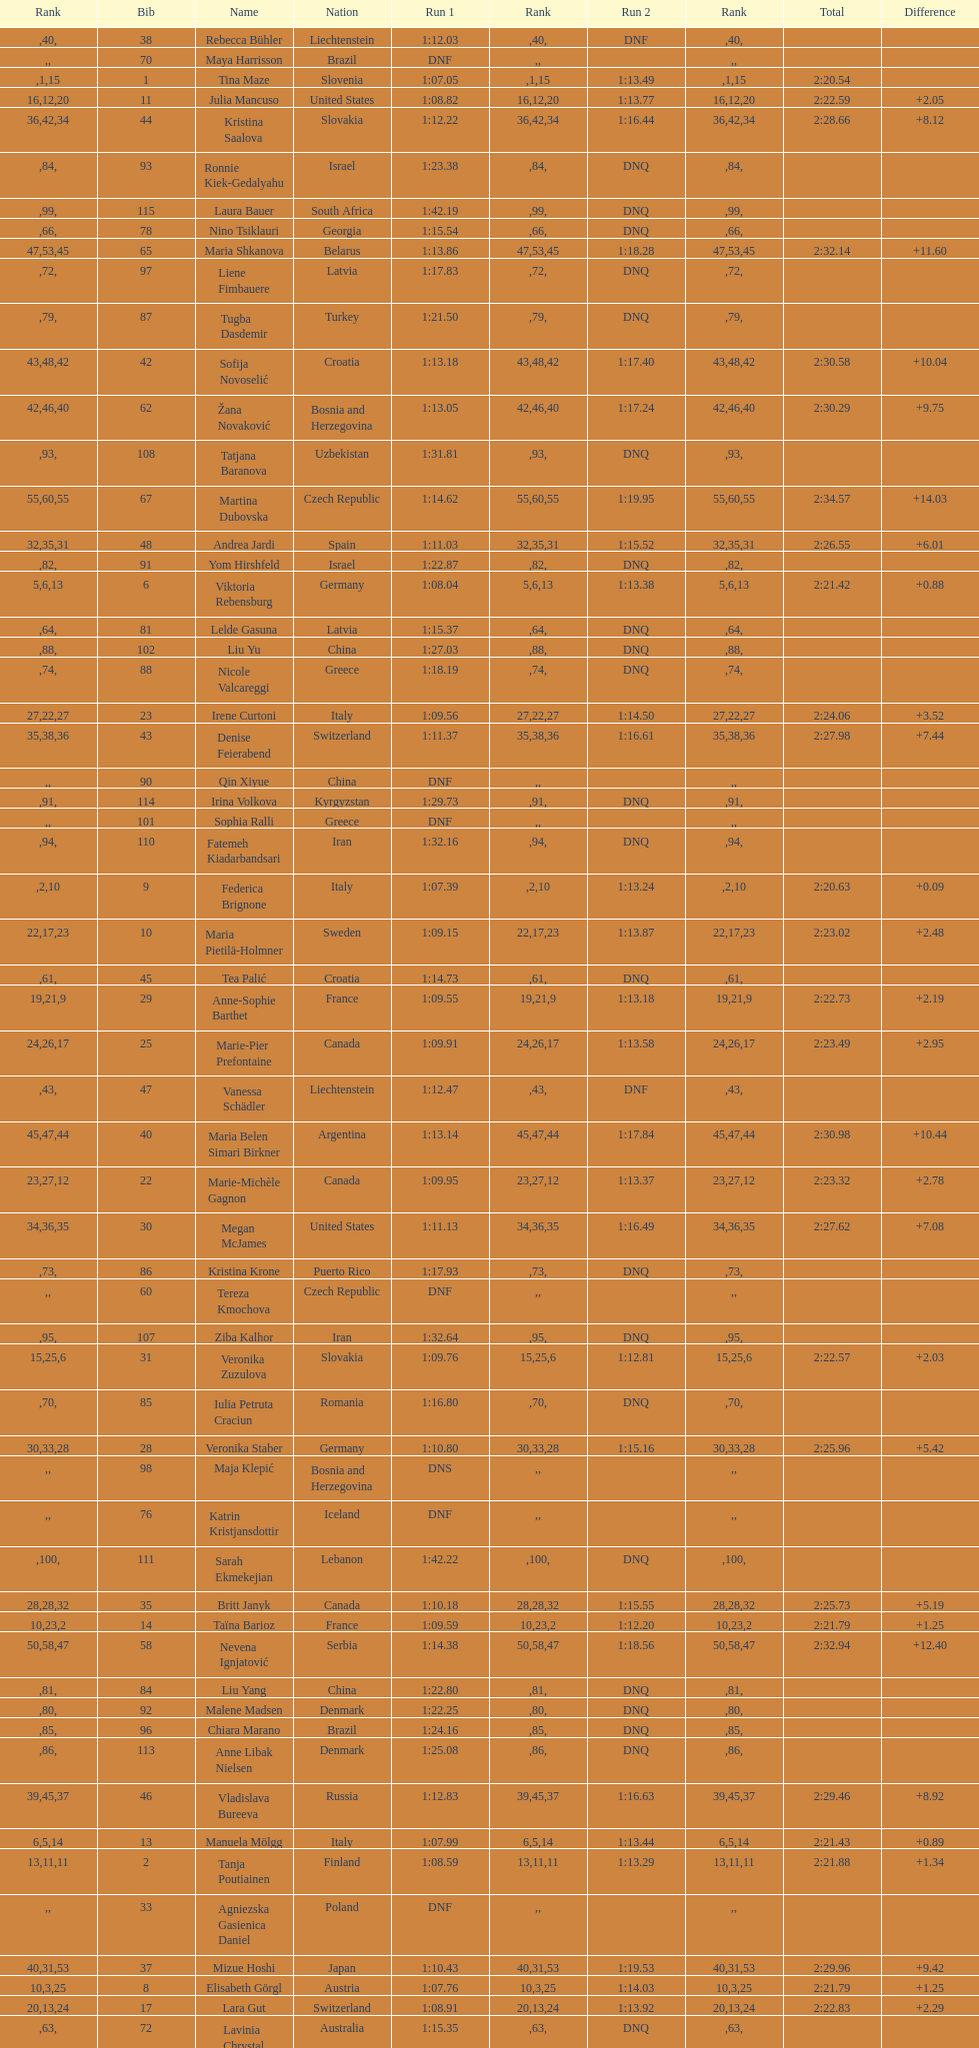Who was the last competitor to actually finish both runs? Martina Dubovska. 